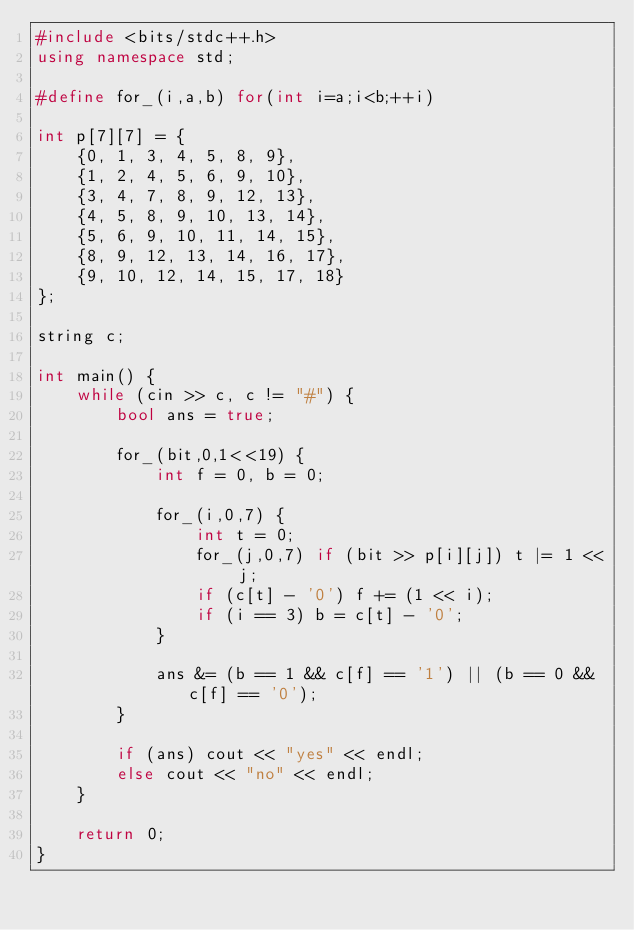<code> <loc_0><loc_0><loc_500><loc_500><_C++_>#include <bits/stdc++.h>
using namespace std;

#define for_(i,a,b) for(int i=a;i<b;++i)

int p[7][7] = {
	{0, 1, 3, 4, 5, 8, 9},
	{1, 2, 4, 5, 6, 9, 10},
	{3, 4, 7, 8, 9, 12, 13},
	{4, 5, 8, 9, 10, 13, 14},
	{5, 6, 9, 10, 11, 14, 15},
	{8, 9, 12, 13, 14, 16, 17},
	{9, 10, 12, 14, 15, 17, 18}
};

string c;

int main() {
	while (cin >> c, c != "#") {
		bool ans = true;
		
		for_(bit,0,1<<19) {
			int f = 0, b = 0;
			
			for_(i,0,7) {
				int t = 0;
				for_(j,0,7) if (bit >> p[i][j]) t |= 1 << j;
				if (c[t] - '0') f += (1 << i);
				if (i == 3) b = c[t] - '0';
			}
			
			ans &= (b == 1 && c[f] == '1') || (b == 0 && c[f] == '0');
		}
		
		if (ans) cout << "yes" << endl;
		else cout << "no" << endl;
	}
	
	return 0;
}</code> 